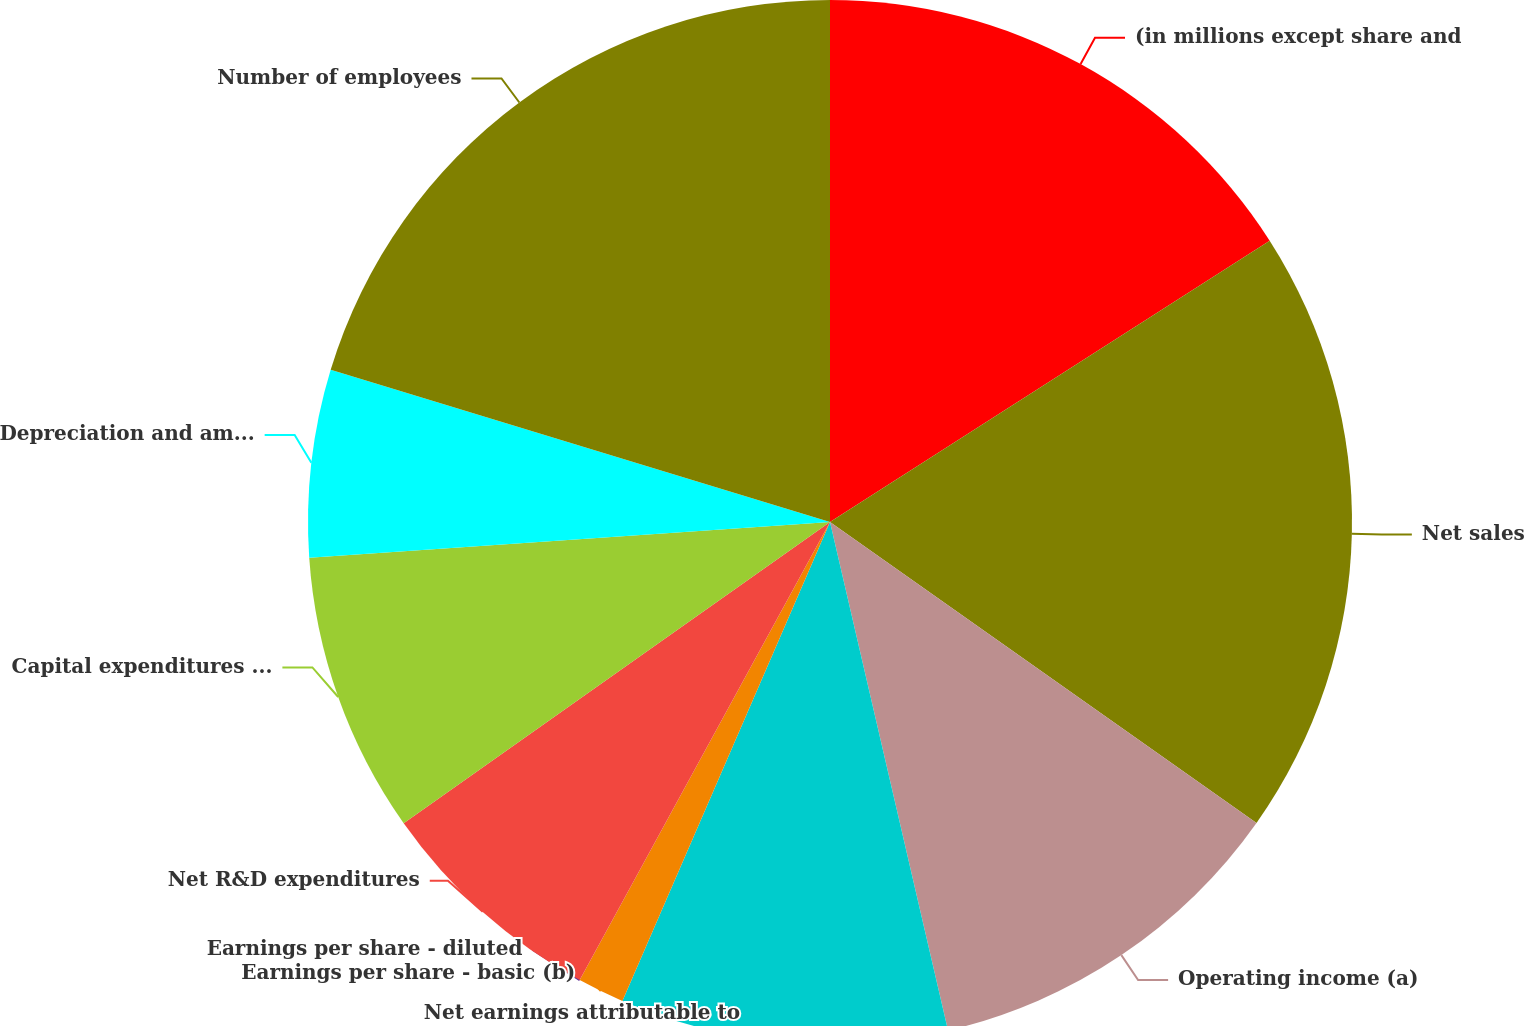<chart> <loc_0><loc_0><loc_500><loc_500><pie_chart><fcel>(in millions except share and<fcel>Net sales<fcel>Operating income (a)<fcel>Net earnings attributable to<fcel>Earnings per share - basic (b)<fcel>Earnings per share - diluted<fcel>Net R&D expenditures<fcel>Capital expenditures including<fcel>Depreciation and amortization<fcel>Number of employees<nl><fcel>15.94%<fcel>18.84%<fcel>11.59%<fcel>10.14%<fcel>1.45%<fcel>0.0%<fcel>7.25%<fcel>8.7%<fcel>5.8%<fcel>20.29%<nl></chart> 